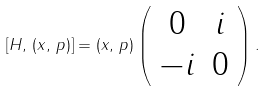<formula> <loc_0><loc_0><loc_500><loc_500>[ { H } , \, ( { x } , \, { p } ) ] = ( { x } , \, { p } ) \left ( \begin{array} { c c } 0 & i \\ - i & 0 \end{array} \right ) .</formula> 